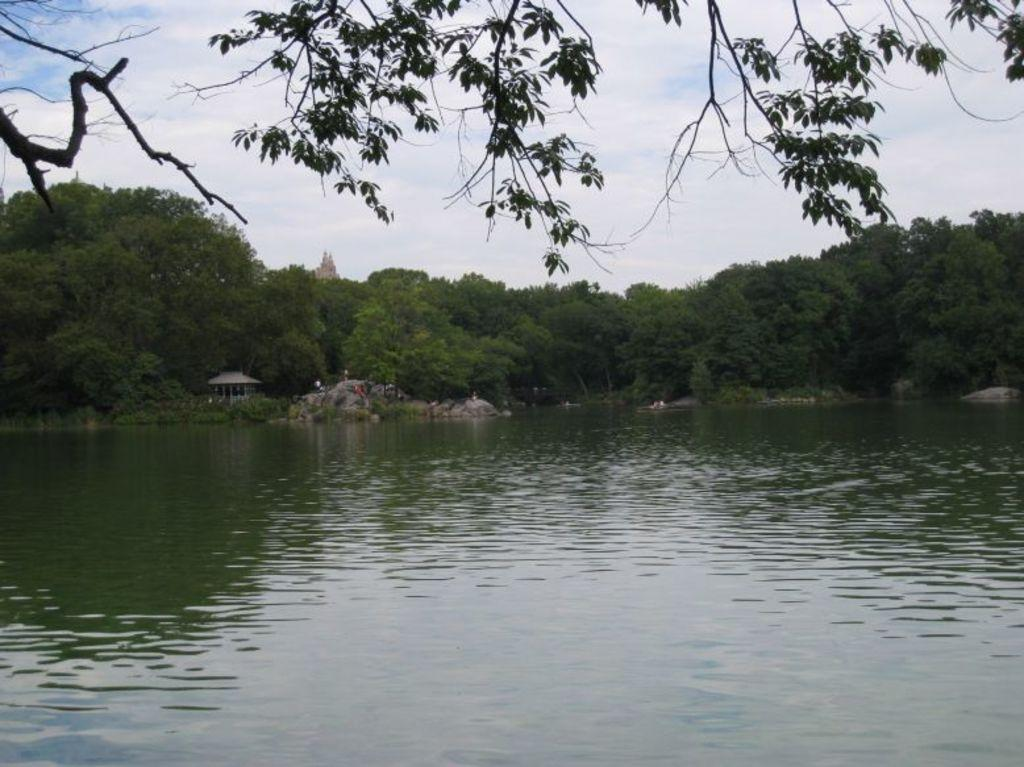What type of natural vegetation can be seen in the image? There are trees in the image. What type of structure is present in the image? There is a temple in the image. What is visible in the sky in the image? The sky is visible in the image. What body of water can be seen in the image? There is a river in the image. Where is the pen located in the image? There is no pen present in the image. Can you tell me how many members are in the team in the image? There is no team present in the image. 